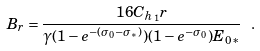<formula> <loc_0><loc_0><loc_500><loc_500>B _ { r } = \frac { 1 6 C _ { h _ { 1 } } r } { \gamma ( 1 - e ^ { - ( \sigma _ { 0 } - \sigma _ { * } ) } ) ( 1 - e ^ { - \sigma _ { 0 } } ) E _ { 0 * } } \ .</formula> 